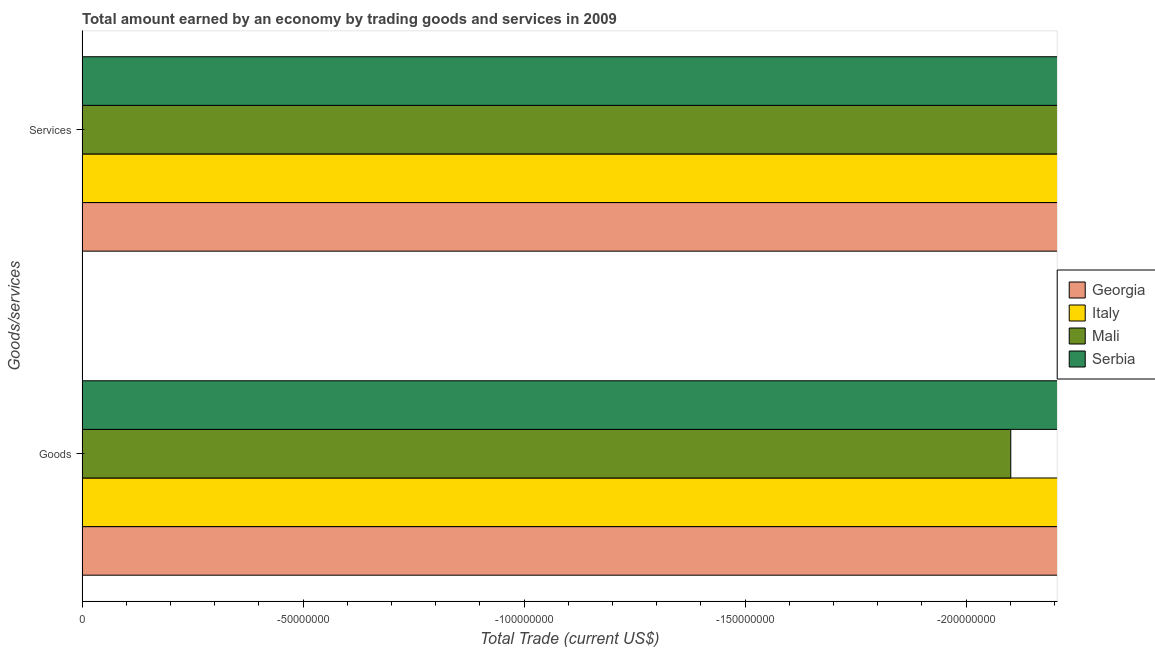Are the number of bars per tick equal to the number of legend labels?
Your response must be concise. No. Are the number of bars on each tick of the Y-axis equal?
Offer a terse response. Yes. How many bars are there on the 1st tick from the top?
Your response must be concise. 0. How many bars are there on the 2nd tick from the bottom?
Keep it short and to the point. 0. What is the label of the 1st group of bars from the top?
Your response must be concise. Services. What is the average amount earned by trading services per country?
Give a very brief answer. 0. In how many countries, is the amount earned by trading goods greater than -60000000 US$?
Offer a terse response. 0. How many countries are there in the graph?
Provide a succinct answer. 4. What is the difference between two consecutive major ticks on the X-axis?
Keep it short and to the point. 5.00e+07. Are the values on the major ticks of X-axis written in scientific E-notation?
Offer a terse response. No. What is the title of the graph?
Your answer should be compact. Total amount earned by an economy by trading goods and services in 2009. What is the label or title of the X-axis?
Offer a terse response. Total Trade (current US$). What is the label or title of the Y-axis?
Provide a short and direct response. Goods/services. What is the Total Trade (current US$) in Georgia in Goods?
Offer a very short reply. 0. What is the Total Trade (current US$) of Italy in Goods?
Your answer should be very brief. 0. What is the Total Trade (current US$) in Mali in Goods?
Your answer should be compact. 0. What is the Total Trade (current US$) in Serbia in Goods?
Provide a short and direct response. 0. What is the total Total Trade (current US$) in Italy in the graph?
Provide a short and direct response. 0. What is the total Total Trade (current US$) in Serbia in the graph?
Your answer should be compact. 0. What is the average Total Trade (current US$) of Mali per Goods/services?
Provide a short and direct response. 0. What is the average Total Trade (current US$) in Serbia per Goods/services?
Offer a very short reply. 0. 